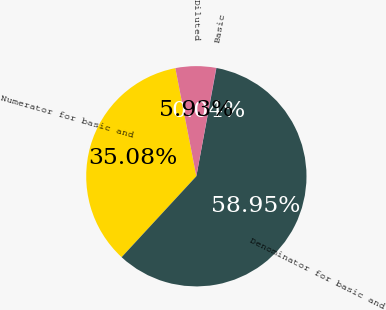Convert chart. <chart><loc_0><loc_0><loc_500><loc_500><pie_chart><fcel>Numerator for basic and<fcel>Denominator for basic and<fcel>Basic<fcel>Diluted<nl><fcel>35.08%<fcel>58.94%<fcel>0.04%<fcel>5.93%<nl></chart> 